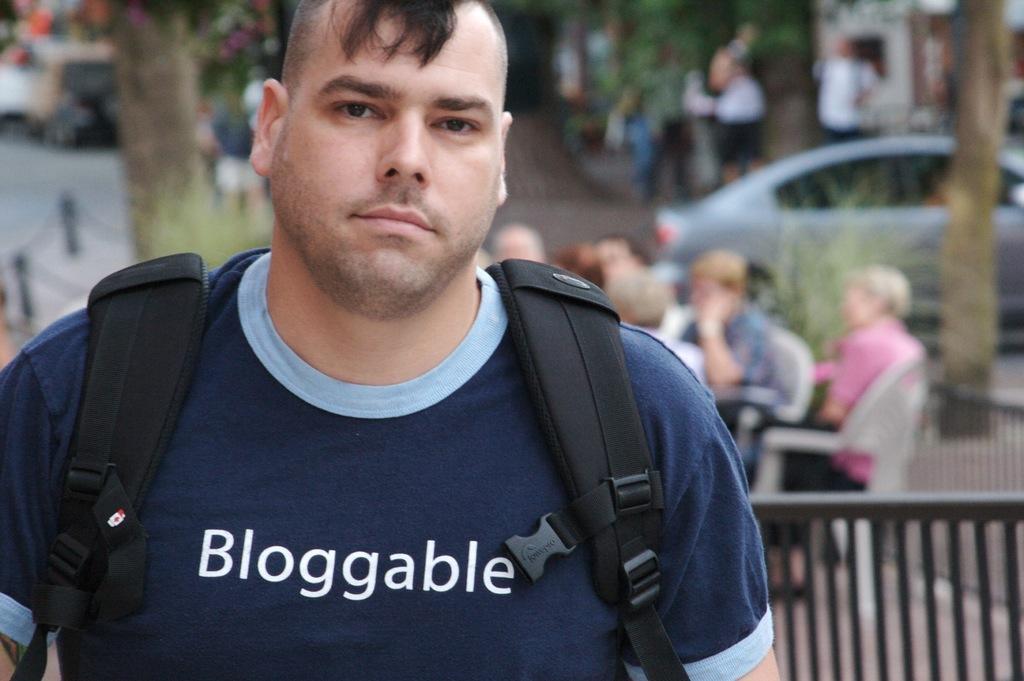Can you describe this image briefly? In this image we can see a few people, some of them are sitting on the chairs, one person is wearing a backpack, there is a railing, a car, tree, and the background is blurred. 